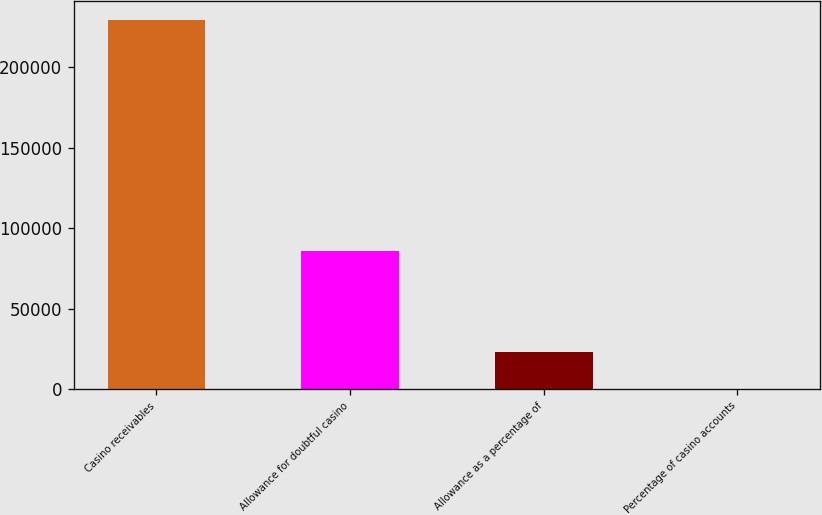Convert chart to OTSL. <chart><loc_0><loc_0><loc_500><loc_500><bar_chart><fcel>Casino receivables<fcel>Allowance for doubtful casino<fcel>Allowance as a percentage of<fcel>Percentage of casino accounts<nl><fcel>229318<fcel>85547<fcel>22957<fcel>28<nl></chart> 